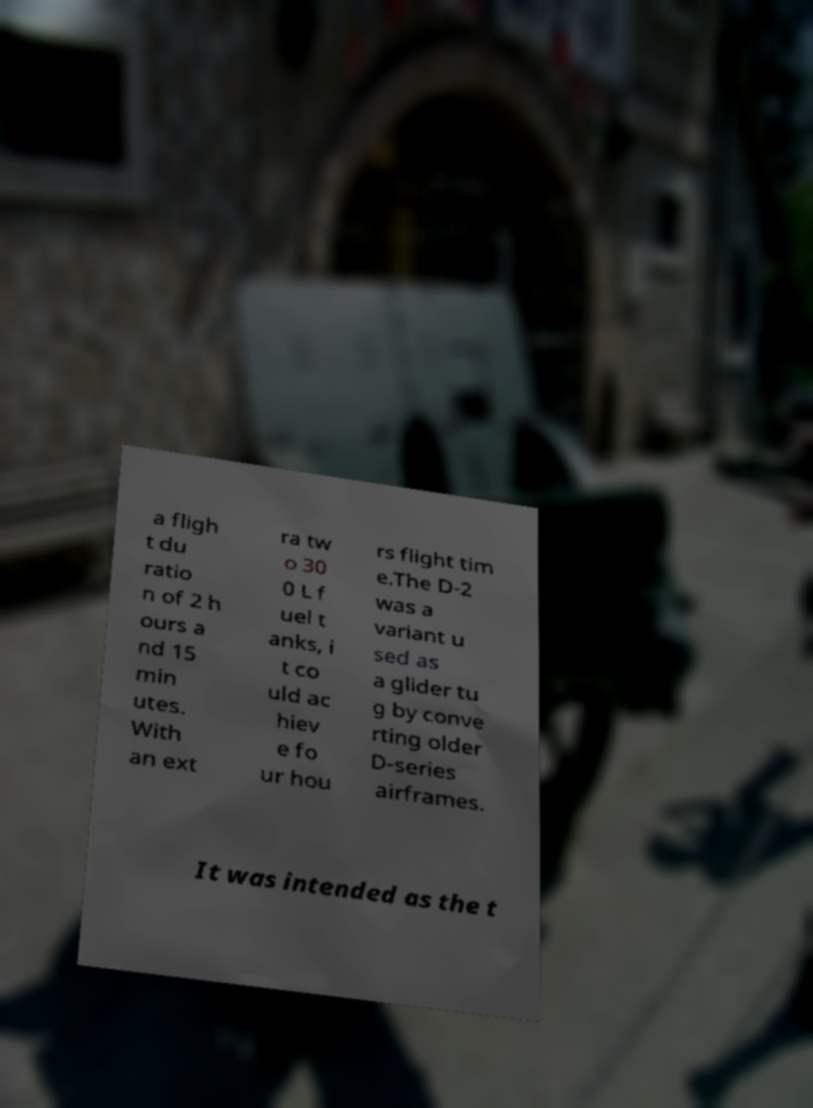What messages or text are displayed in this image? I need them in a readable, typed format. a fligh t du ratio n of 2 h ours a nd 15 min utes. With an ext ra tw o 30 0 L f uel t anks, i t co uld ac hiev e fo ur hou rs flight tim e.The D-2 was a variant u sed as a glider tu g by conve rting older D-series airframes. It was intended as the t 